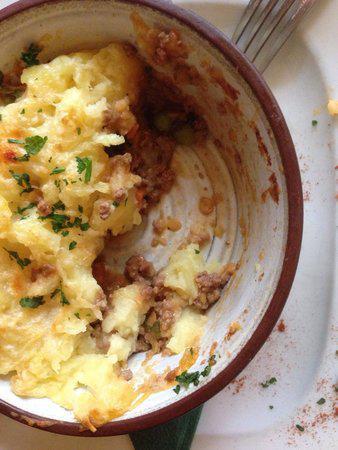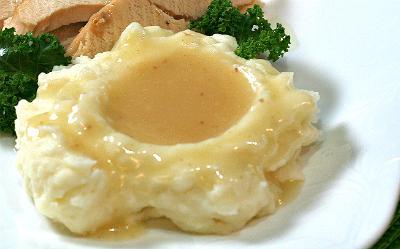The first image is the image on the left, the second image is the image on the right. Analyze the images presented: Is the assertion "the mashed potato on the right image is shaped like a bowl of gravy." valid? Answer yes or no. Yes. 